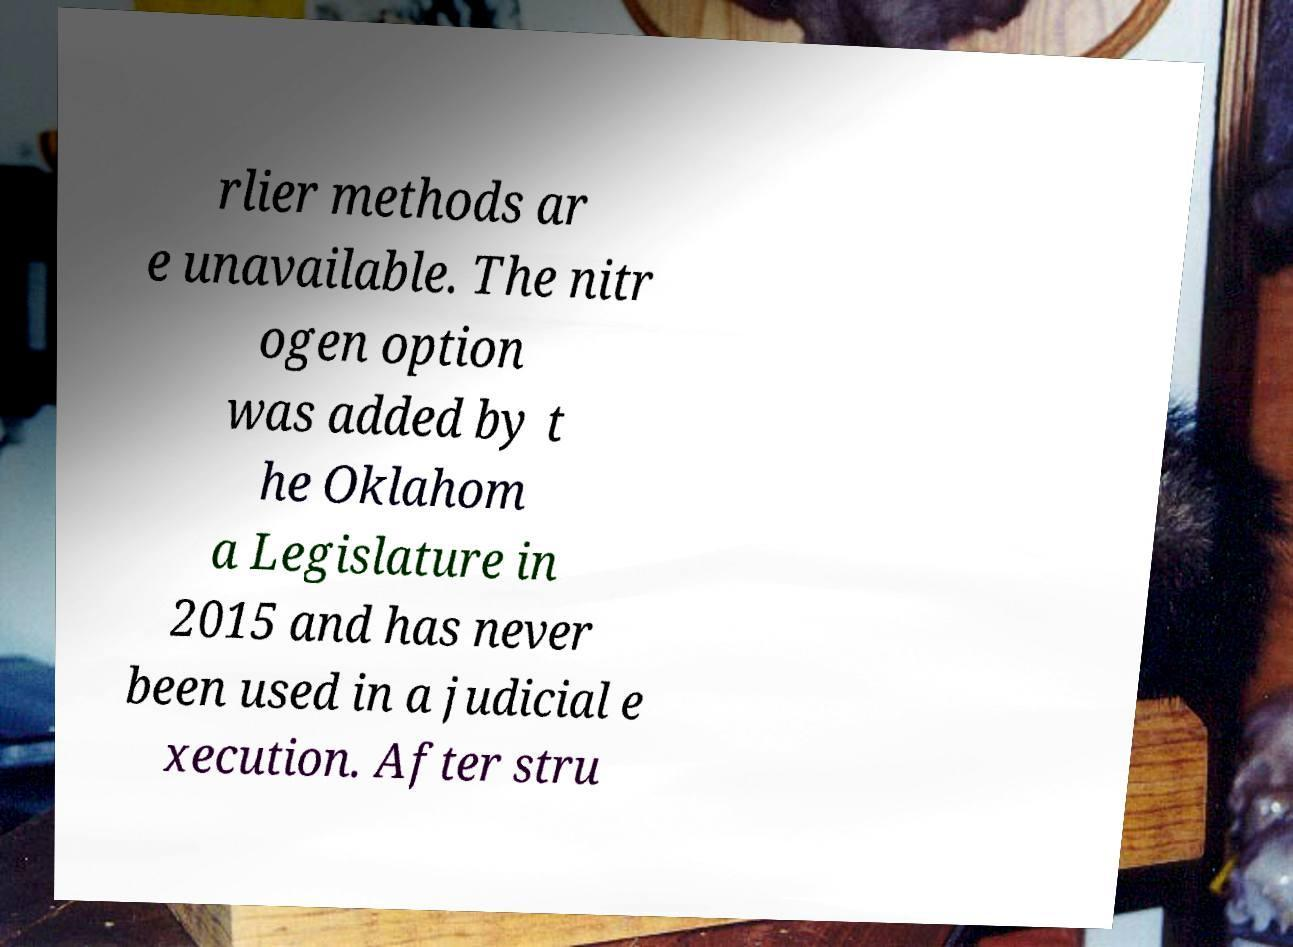Could you assist in decoding the text presented in this image and type it out clearly? rlier methods ar e unavailable. The nitr ogen option was added by t he Oklahom a Legislature in 2015 and has never been used in a judicial e xecution. After stru 